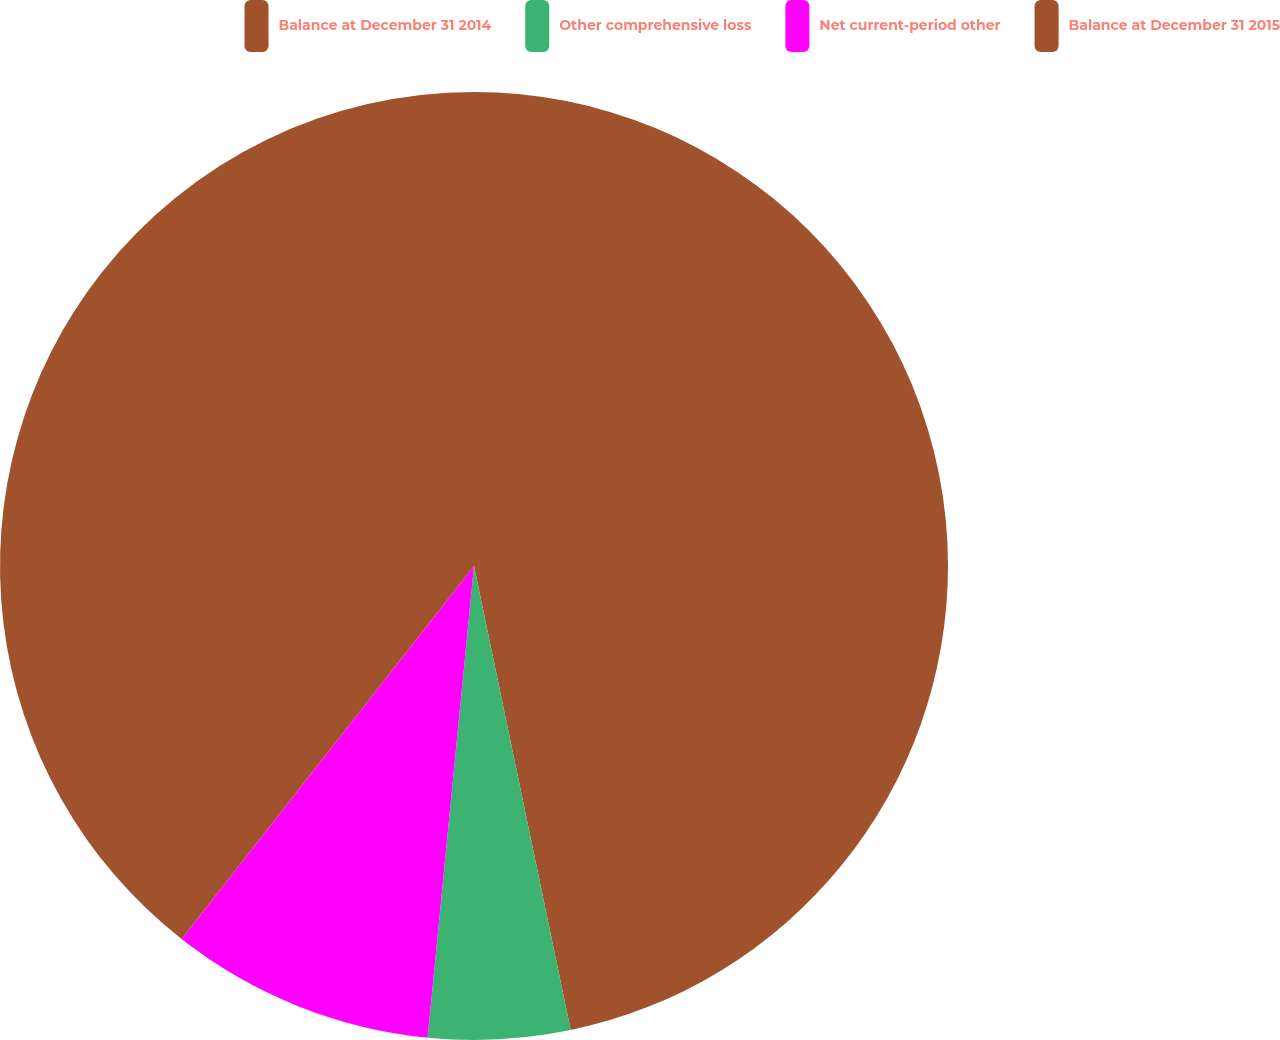<chart> <loc_0><loc_0><loc_500><loc_500><pie_chart><fcel>Balance at December 31 2014<fcel>Other comprehensive loss<fcel>Net current-period other<fcel>Balance at December 31 2015<nl><fcel>46.73%<fcel>4.83%<fcel>9.02%<fcel>39.42%<nl></chart> 